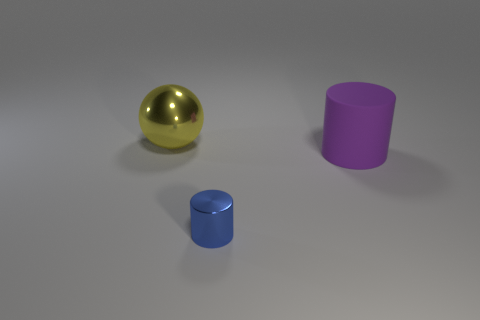There is a metallic thing that is in front of the purple cylinder; is it the same size as the large yellow object?
Your response must be concise. No. What is the color of the shiny object in front of the sphere?
Your answer should be compact. Blue. There is a tiny shiny thing that is the same shape as the large purple matte thing; what color is it?
Provide a succinct answer. Blue. There is a object that is to the left of the metallic object that is in front of the yellow shiny thing; how many large purple things are to the right of it?
Make the answer very short. 1. Is there anything else that has the same material as the big sphere?
Your response must be concise. Yes. Is the number of cylinders to the right of the sphere less than the number of yellow objects?
Ensure brevity in your answer.  No. Do the tiny metal cylinder and the shiny ball have the same color?
Give a very brief answer. No. The other thing that is the same shape as the tiny metallic object is what size?
Your response must be concise. Large. How many small blue cylinders are the same material as the large cylinder?
Provide a short and direct response. 0. Are the object that is in front of the purple thing and the large yellow thing made of the same material?
Provide a succinct answer. Yes. 